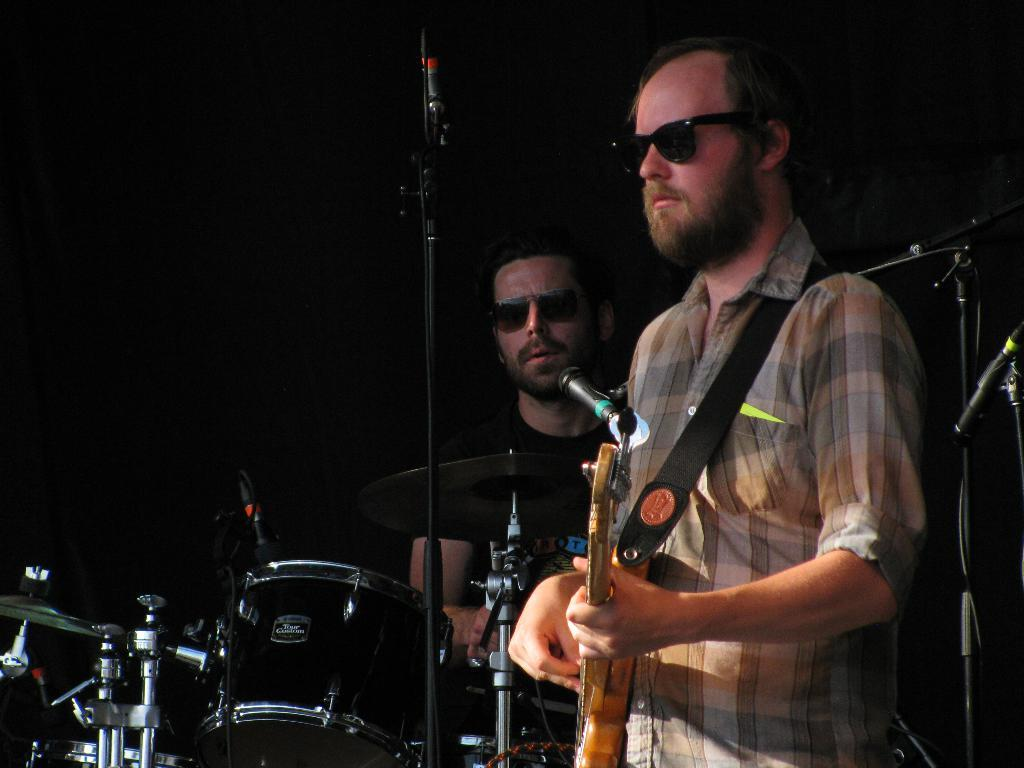What is the person on the left side of the image holding? The person on the left side of the image is holding a guitar. What is the person on the right side of the image doing? The person on the right side of the image is playing drums. What is in front of the musicians in the image? There is a microphone in front of the musicians. What color is the background of the image? The background of the image is black. What type of flesh can be seen on the guitar in the image? There is no flesh present on the guitar in the image; it is a musical instrument made of wood and other materials. 